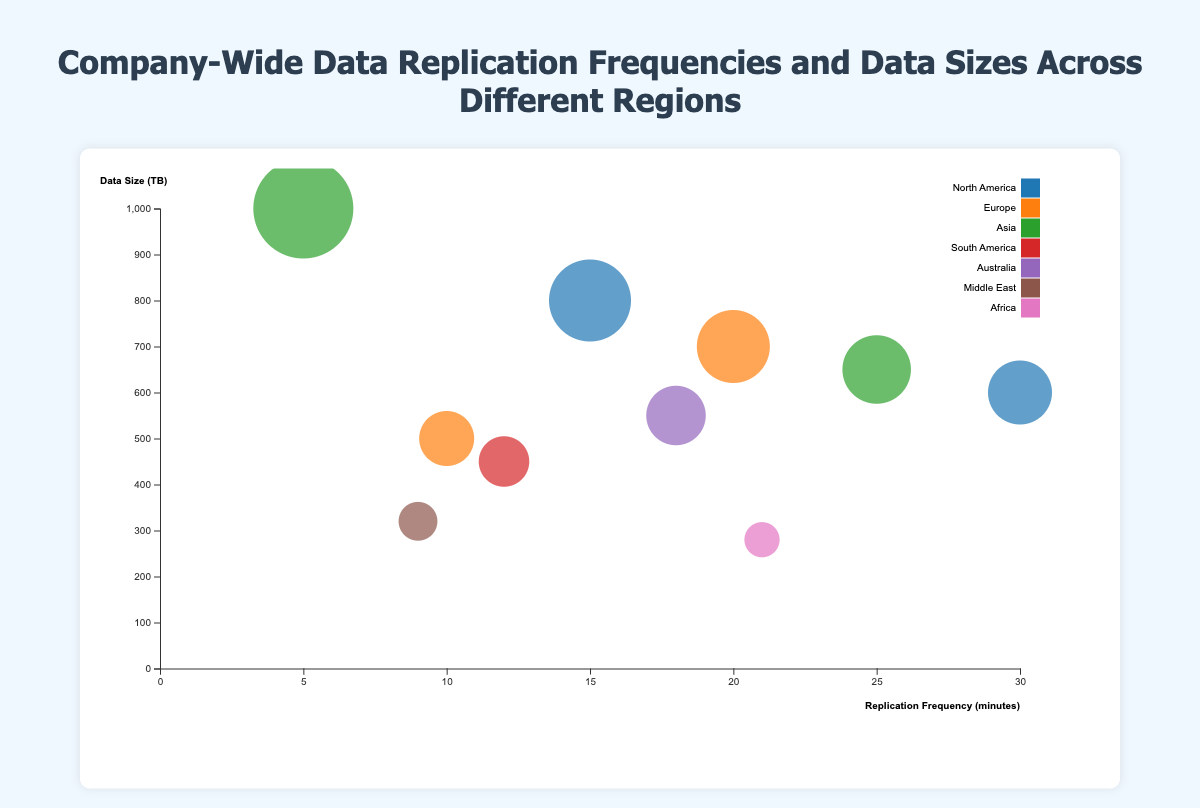what is the title of the figure? The title is displayed at the top of the figure. It is "Company-Wide Data Replication Frequencies and Data Sizes Across Different Regions".
Answer: Company-Wide Data Replication Frequencies and Data Sizes Across Different Regions How many regions are represented in the chart? The legend on the right side of the figure shows different colors representing different regions, which include North America, Europe, Asia, South America, Australia, Middle East, and Africa. Counting these gives a total of 7 regions.
Answer: 7 Which data center has the highest replication frequency? To find this, look for the data bubble furthest to the right on the x-axis, representing the highest replication frequency value. This is the San Francisco data center in North America with a replication frequency of 30 minutes.
Answer: San Francisco What is the replication frequency and data size of the Singapore data center? Identify the Singapore data center by locating the corresponding data point in the Asia region on the chart (color-coded). The tooltip or labels near the dot indicate a replication frequency of 25 minutes and a data size of 650 TB.
Answer: 25 minutes, 650 TB Which region has the data center with the smallest data size, and what is that size? The smallest data size can be found by locating the smallest bubble on the y-axis. This corresponds to Johannesburg in Africa with a data size of 280 TB.
Answer: Africa, 280 TB Compare the data size between the Tokyo and New York data centers. Which one is larger? Find the Tokyo and New York data centers on the chart and compare their bubble sizes or their y-axis positions. Tokyo (1000 TB) is significantly larger than New York (800 TB).
Answer: Tokyo How does the Sydney data center's replication frequency compare to the Dubai data center? Locate Sydney and Dubai on the chart and compare their x-axis positions. Sydney's replication frequency (18 minutes) is higher than Dubai's (9 minutes).
Answer: Sydney has a higher replication frequency than Dubai If a data center needs to be selected for its high data size but low replication frequency, which data center should you pick? Identify data centers with high y-axis positions (large data sizes) but low x-axis positions (low replication frequencies). The Tokyo data center, despite having the largest data size (1000 TB), has one of the lowest replication frequencies (5 minutes).
Answer: Tokyo What's the average data size for the data centers in North America? North America has two data centers: New York (800 TB) and San Francisco (600 TB). Sum the data sizes (800 + 600 = 1400) and divide by the number of data centers (1400 / 2 = 700).
Answer: 700 TB Which region shows the greatest variation in replication frequencies among its data centers? Compare the range of replication frequencies within each region by checking the x-axis span of their data points. North America has the greatest variation, ranging from 15 minutes (New York) to 30 minutes (San Francisco), giving a variation of 15 minutes.
Answer: North America 